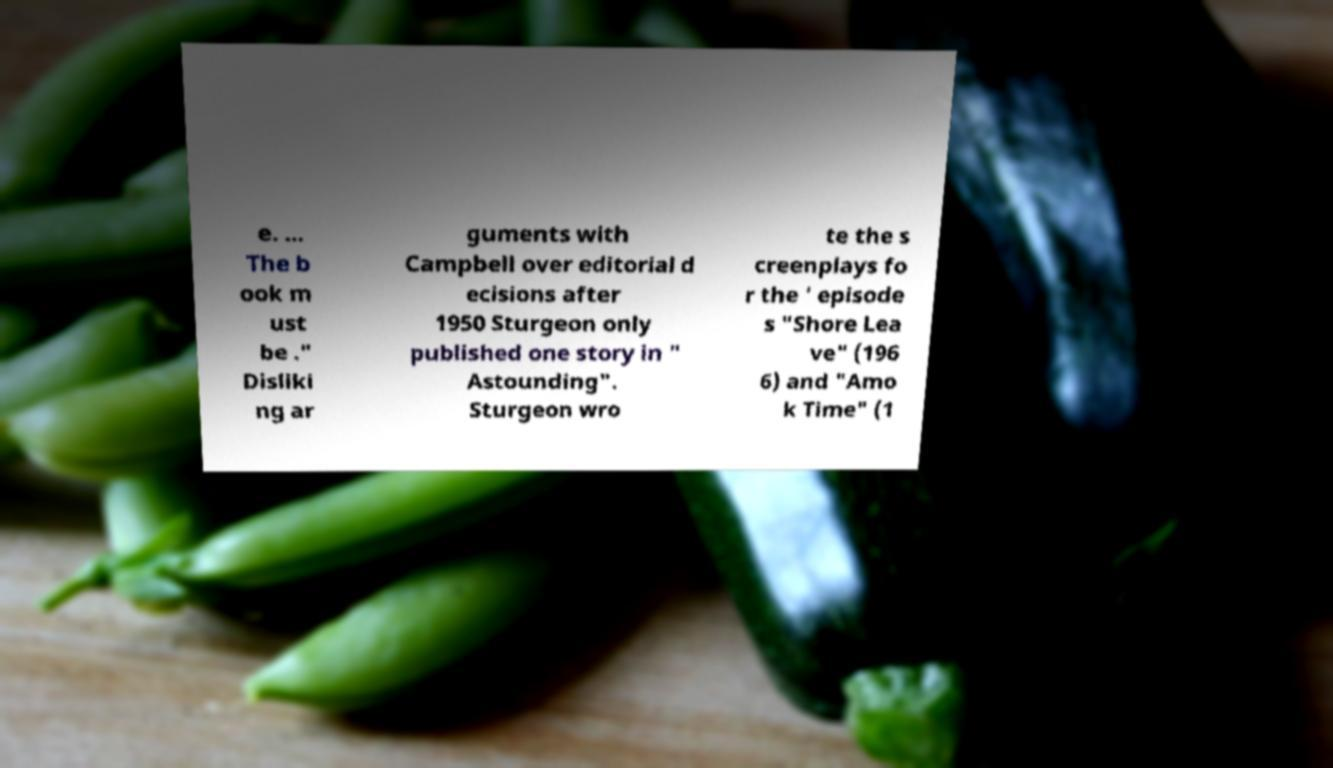Please read and relay the text visible in this image. What does it say? e. ... The b ook m ust be ." Disliki ng ar guments with Campbell over editorial d ecisions after 1950 Sturgeon only published one story in " Astounding". Sturgeon wro te the s creenplays fo r the ' episode s "Shore Lea ve" (196 6) and "Amo k Time" (1 